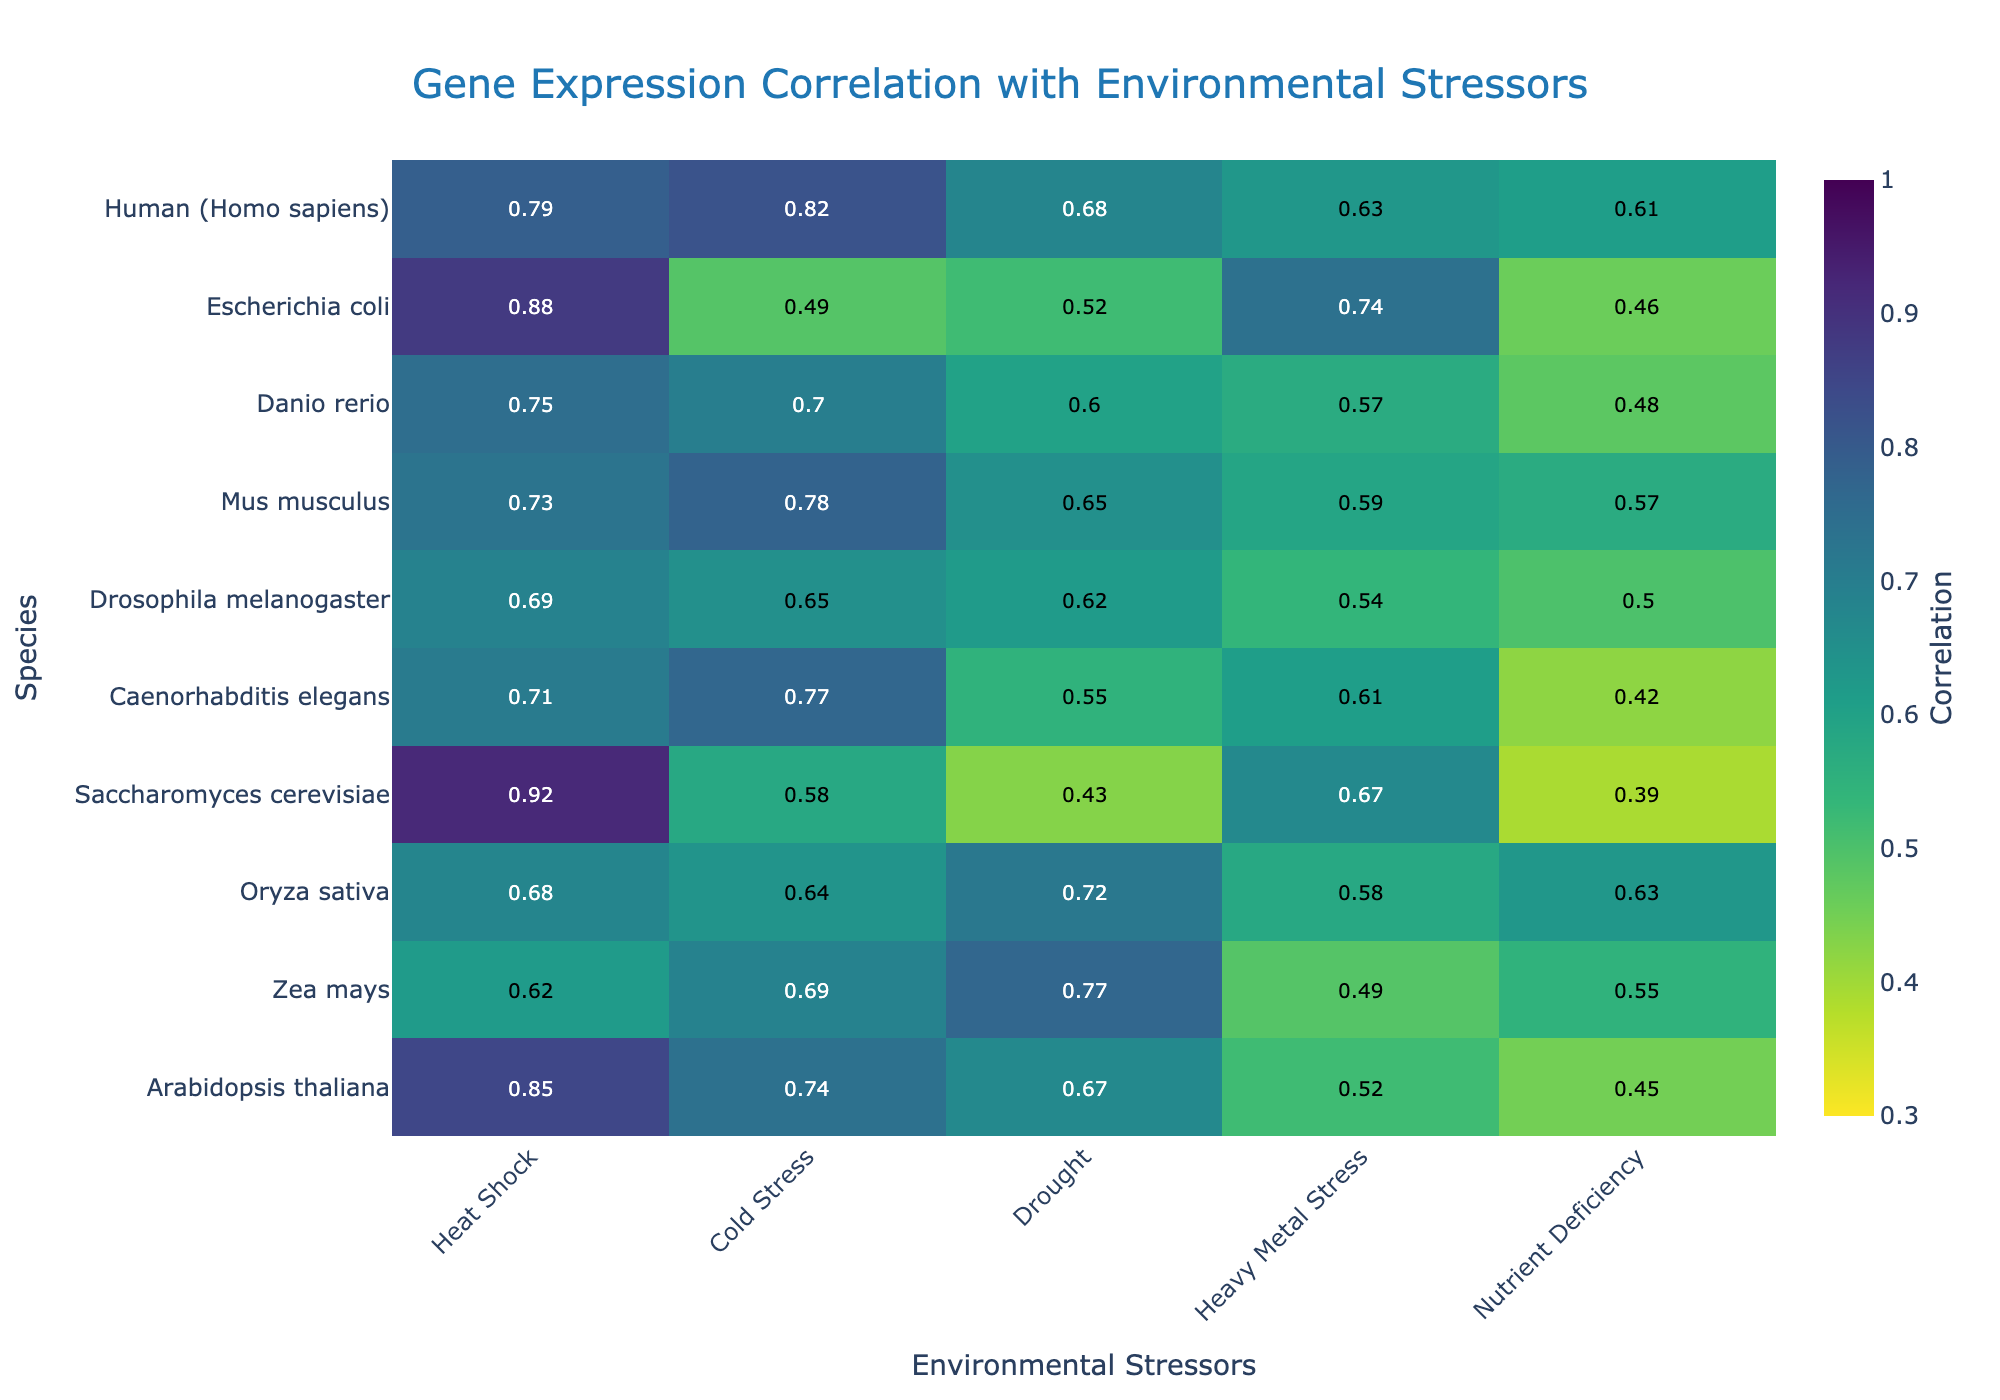What's the title of the figure? The title of the figure is located at the top of the plot, which provides a summary or description of what the figure represents. In this case, it is "Gene Expression Correlation with Environmental Stressors".
Answer: Gene Expression Correlation with Environmental Stressors Which species shows the highest correlation with Heat Shock? To find the species with the highest correlation with Heat Shock, we look for the highest value in the Heat Shock column. Saccharomyces cerevisiae has the highest value of 0.92.
Answer: Saccharomyces cerevisiae What is the average correlation of Mus musculus across all environmental stressors? To calculate the average, sum the correlation values for Mus musculus across all stressors and divide by the number of stressors. The values are 0.73, 0.78, 0.65, 0.59, and 0.57, summing to 3.32. Dividing by 5 gives 0.664.
Answer: 0.664 Which species has the lowest correlation with Drought? To find the species with the lowest correlation with Drought, we look for the smallest value in the Drought column. Saccharomyces cerevisiae has the lowest value of 0.43.
Answer: Saccharomyces cerevisiae How does the correlation of Oryza sativa with Cold Stress compare to its correlation with Heavy Metal Stress? To compare the correlations of Oryza sativa between Cold Stress and Heavy Metal Stress, we look at the respective values. The correlation with Cold Stress is 0.64 and with Heavy Metal Stress is 0.58. Since 0.64 > 0.58, Oryza sativa has a higher correlation with Cold Stress than with Heavy Metal Stress.
Answer: Higher with Cold Stress Identify the environmental stressor that shows the highest average correlation across all species. To find the environmental stressor with the highest average correlation, calculate the average correlation for each stressor. Sum all correlations for each stressor and divide by the number of species (10). Comparing the averages, Heat Shock leads with the highest average (sum = 7.62, average = 0.762).
Answer: Heat Shock Which two species have the most similar correlation profiles across all stressors? To determine the most similar correlation profiles, compare the correlation values of each species across all stressors. Arabidopsis thaliana and Zea mays look very similar across all stressors, with slight differences in each value.
Answer: Arabidopsis thaliana and Zea mays 